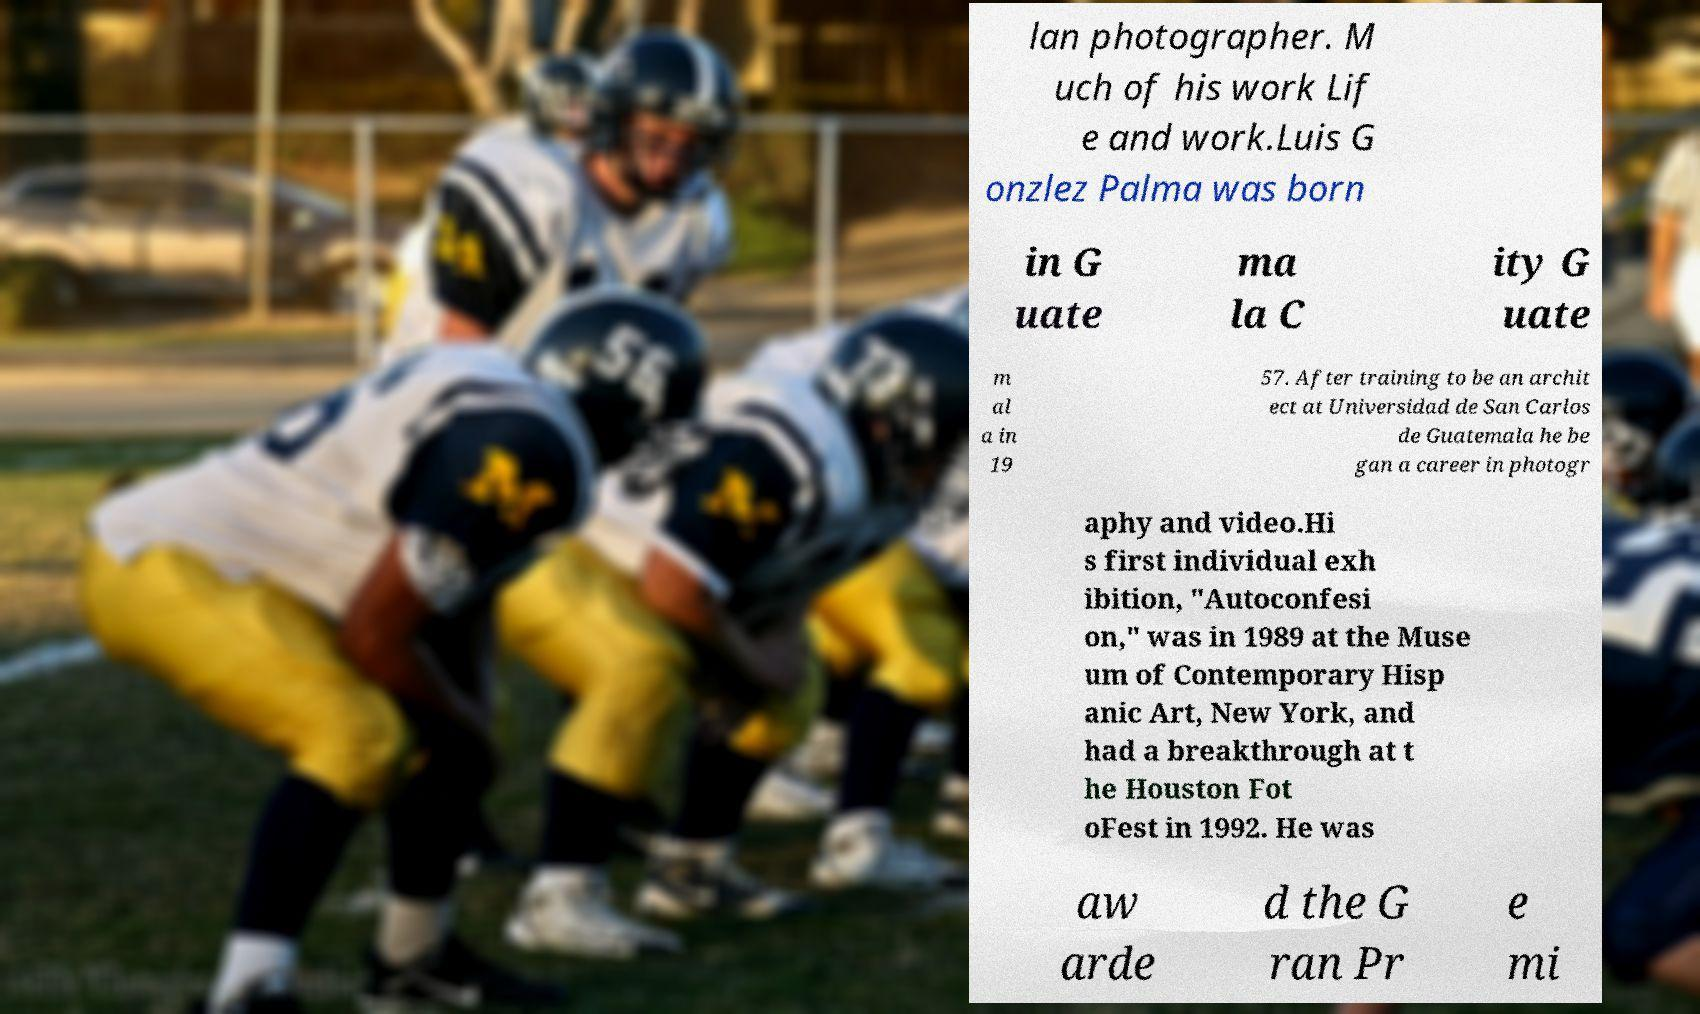I need the written content from this picture converted into text. Can you do that? lan photographer. M uch of his work Lif e and work.Luis G onzlez Palma was born in G uate ma la C ity G uate m al a in 19 57. After training to be an archit ect at Universidad de San Carlos de Guatemala he be gan a career in photogr aphy and video.Hi s first individual exh ibition, "Autoconfesi on," was in 1989 at the Muse um of Contemporary Hisp anic Art, New York, and had a breakthrough at t he Houston Fot oFest in 1992. He was aw arde d the G ran Pr e mi 